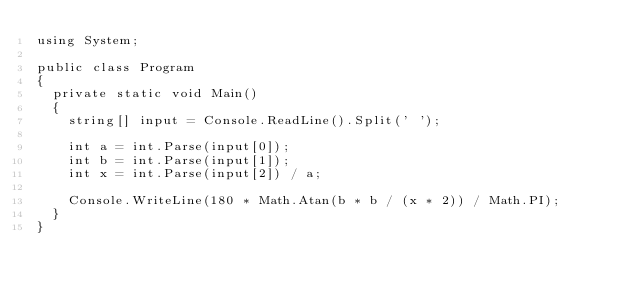<code> <loc_0><loc_0><loc_500><loc_500><_C#_>using System;

public class Program
{
  private static void Main()
  {
    string[] input = Console.ReadLine().Split(' ');
    
    int a = int.Parse(input[0]);
    int b = int.Parse(input[1]);
    int x = int.Parse(input[2]) / a;
    
    Console.WriteLine(180 * Math.Atan(b * b / (x * 2)) / Math.PI);
  }
}
 </code> 